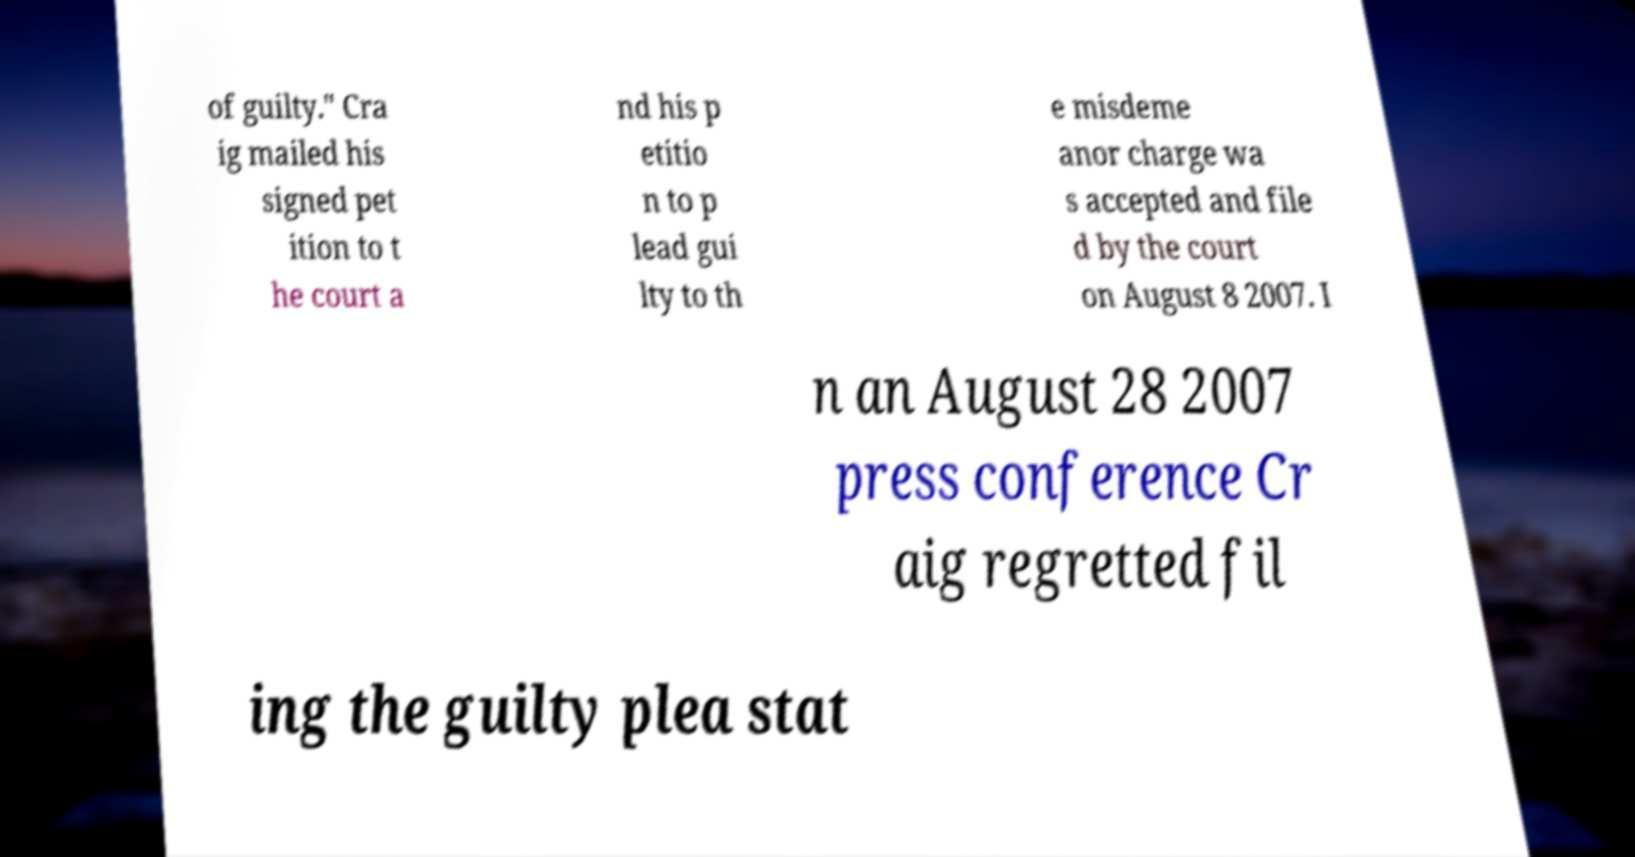There's text embedded in this image that I need extracted. Can you transcribe it verbatim? of guilty." Cra ig mailed his signed pet ition to t he court a nd his p etitio n to p lead gui lty to th e misdeme anor charge wa s accepted and file d by the court on August 8 2007. I n an August 28 2007 press conference Cr aig regretted fil ing the guilty plea stat 